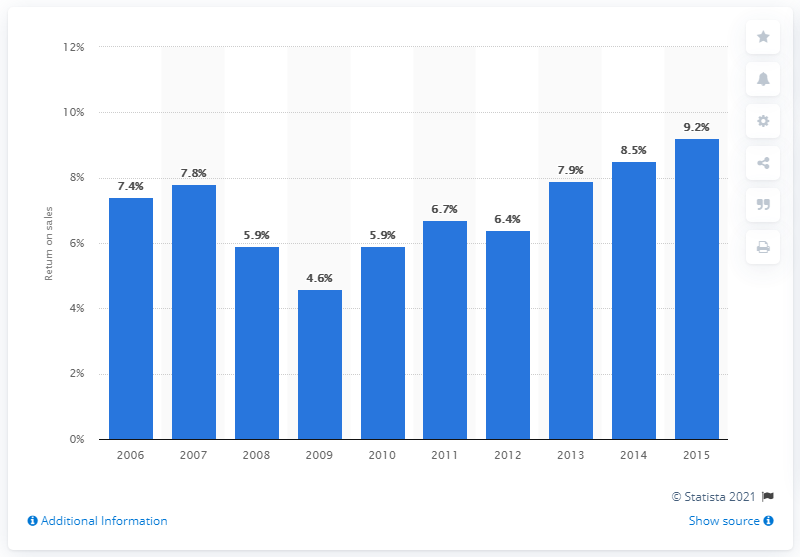Identify some key points in this picture. The return on sales of the top 100 industry players in 2010 was 5.9%. 